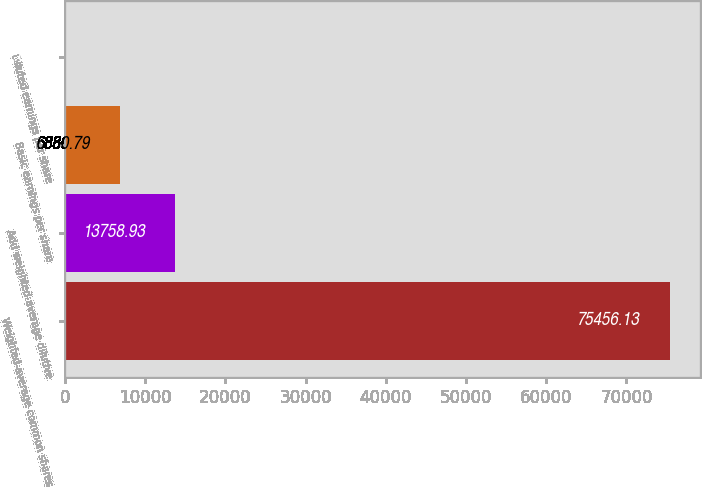<chart> <loc_0><loc_0><loc_500><loc_500><bar_chart><fcel>Weighted-average common shares<fcel>Add weighted-average dilutive<fcel>Basic earnings per share<fcel>Diluted earnings per share<nl><fcel>75456.1<fcel>13758.9<fcel>6880.79<fcel>2.65<nl></chart> 